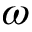Convert formula to latex. <formula><loc_0><loc_0><loc_500><loc_500>\omega</formula> 